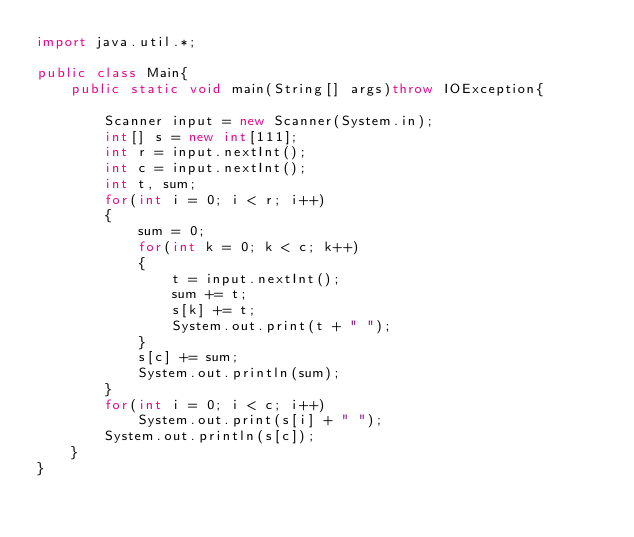Convert code to text. <code><loc_0><loc_0><loc_500><loc_500><_Java_>import java.util.*;

public class Main{
    public static void main(String[] args)throw IOException{
        
        Scanner input = new Scanner(System.in);
        int[] s = new int[111];
        int r = input.nextInt();
        int c = input.nextInt();
        int t, sum;
        for(int i = 0; i < r; i++)
        {
            sum = 0;
            for(int k = 0; k < c; k++)
            {
                t = input.nextInt();
                sum += t;
                s[k] += t;
                System.out.print(t + " ");
            }
            s[c] += sum;
            System.out.println(sum);
        }
        for(int i = 0; i < c; i++)
            System.out.print(s[i] + " ");
        System.out.println(s[c]);
    }
}</code> 